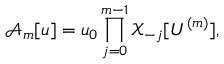<formula> <loc_0><loc_0><loc_500><loc_500>\mathcal { A } _ { m } [ u ] = u _ { 0 } \prod _ { j = 0 } ^ { m - 1 } \mathcal { X } _ { - j } [ U ^ { ( m ) } ] ,</formula> 